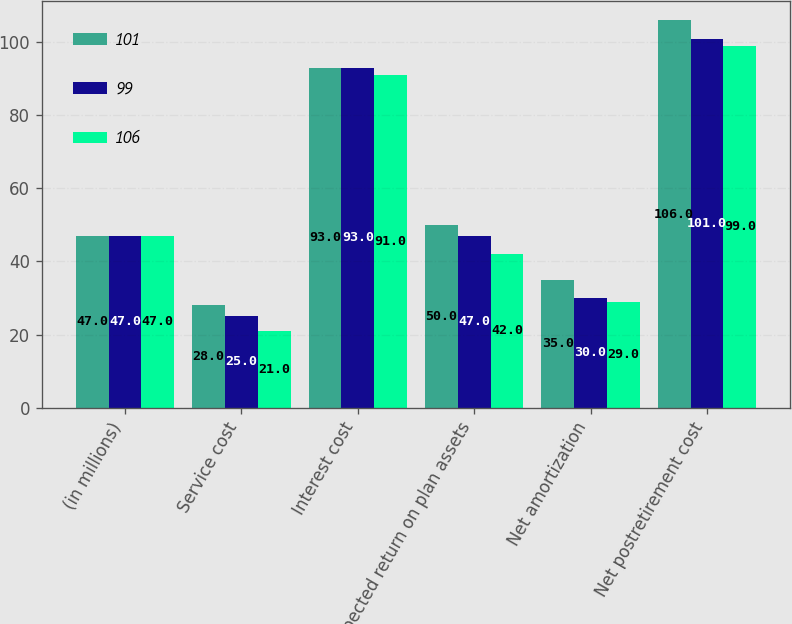Convert chart to OTSL. <chart><loc_0><loc_0><loc_500><loc_500><stacked_bar_chart><ecel><fcel>(in millions)<fcel>Service cost<fcel>Interest cost<fcel>Expected return on plan assets<fcel>Net amortization<fcel>Net postretirement cost<nl><fcel>101<fcel>47<fcel>28<fcel>93<fcel>50<fcel>35<fcel>106<nl><fcel>99<fcel>47<fcel>25<fcel>93<fcel>47<fcel>30<fcel>101<nl><fcel>106<fcel>47<fcel>21<fcel>91<fcel>42<fcel>29<fcel>99<nl></chart> 